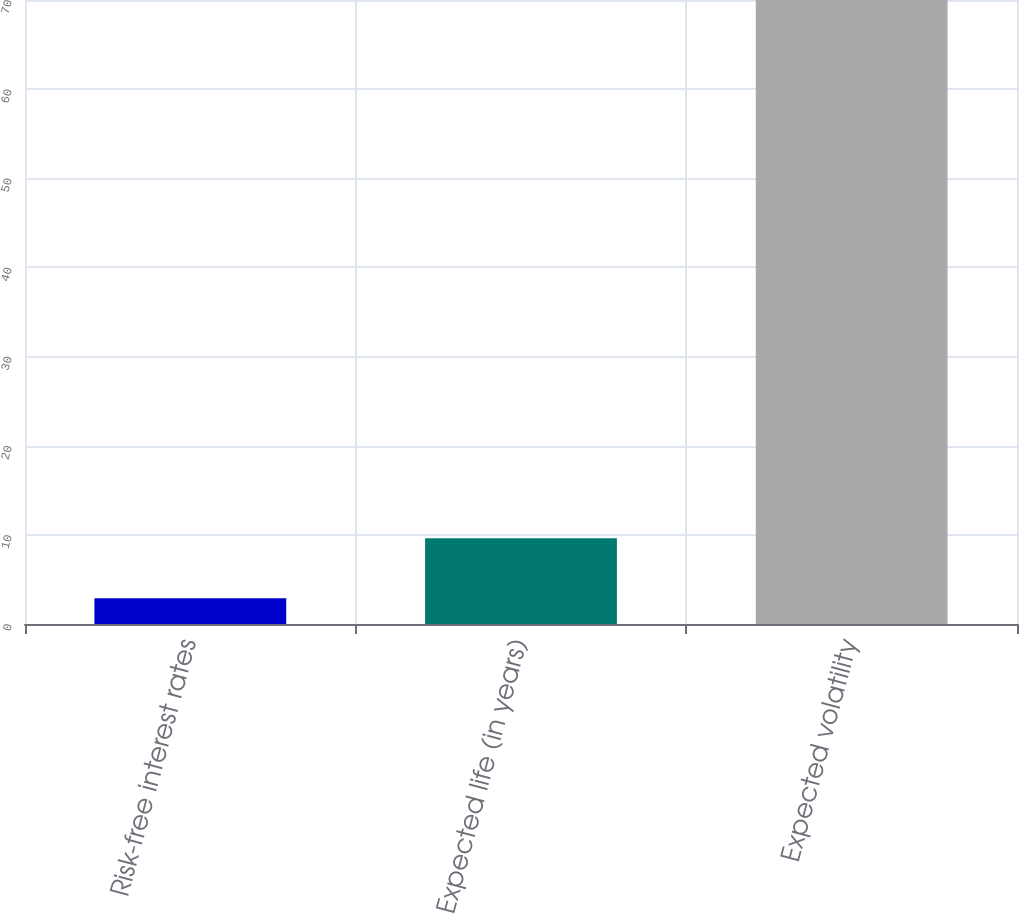Convert chart. <chart><loc_0><loc_0><loc_500><loc_500><bar_chart><fcel>Risk-free interest rates<fcel>Expected life (in years)<fcel>Expected volatility<nl><fcel>2.9<fcel>9.61<fcel>70<nl></chart> 